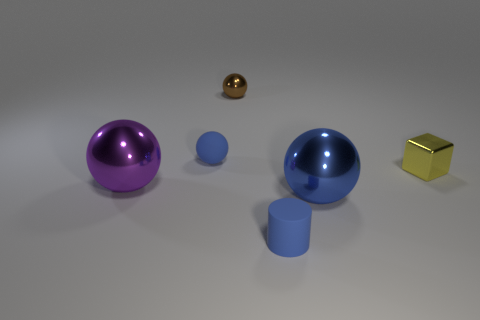Are there any other things of the same color as the block?
Offer a very short reply. No. There is a rubber thing to the left of the small brown metal sphere; what is its shape?
Keep it short and to the point. Sphere. There is a object that is in front of the brown object and behind the yellow thing; what is its shape?
Your answer should be compact. Sphere. What number of gray objects are tiny matte balls or big blocks?
Keep it short and to the point. 0. Do the big thing behind the big blue metal object and the tiny rubber cylinder have the same color?
Offer a very short reply. No. How big is the blue shiny sphere in front of the tiny metal thing to the right of the large blue metallic thing?
Offer a very short reply. Large. There is a blue ball that is the same size as the purple metal thing; what is its material?
Make the answer very short. Metal. How many other objects are there of the same size as the purple metal thing?
Make the answer very short. 1. How many blocks are either big purple metallic things or blue things?
Keep it short and to the point. 0. Are there any other things that are the same material as the tiny blue sphere?
Give a very brief answer. Yes. 